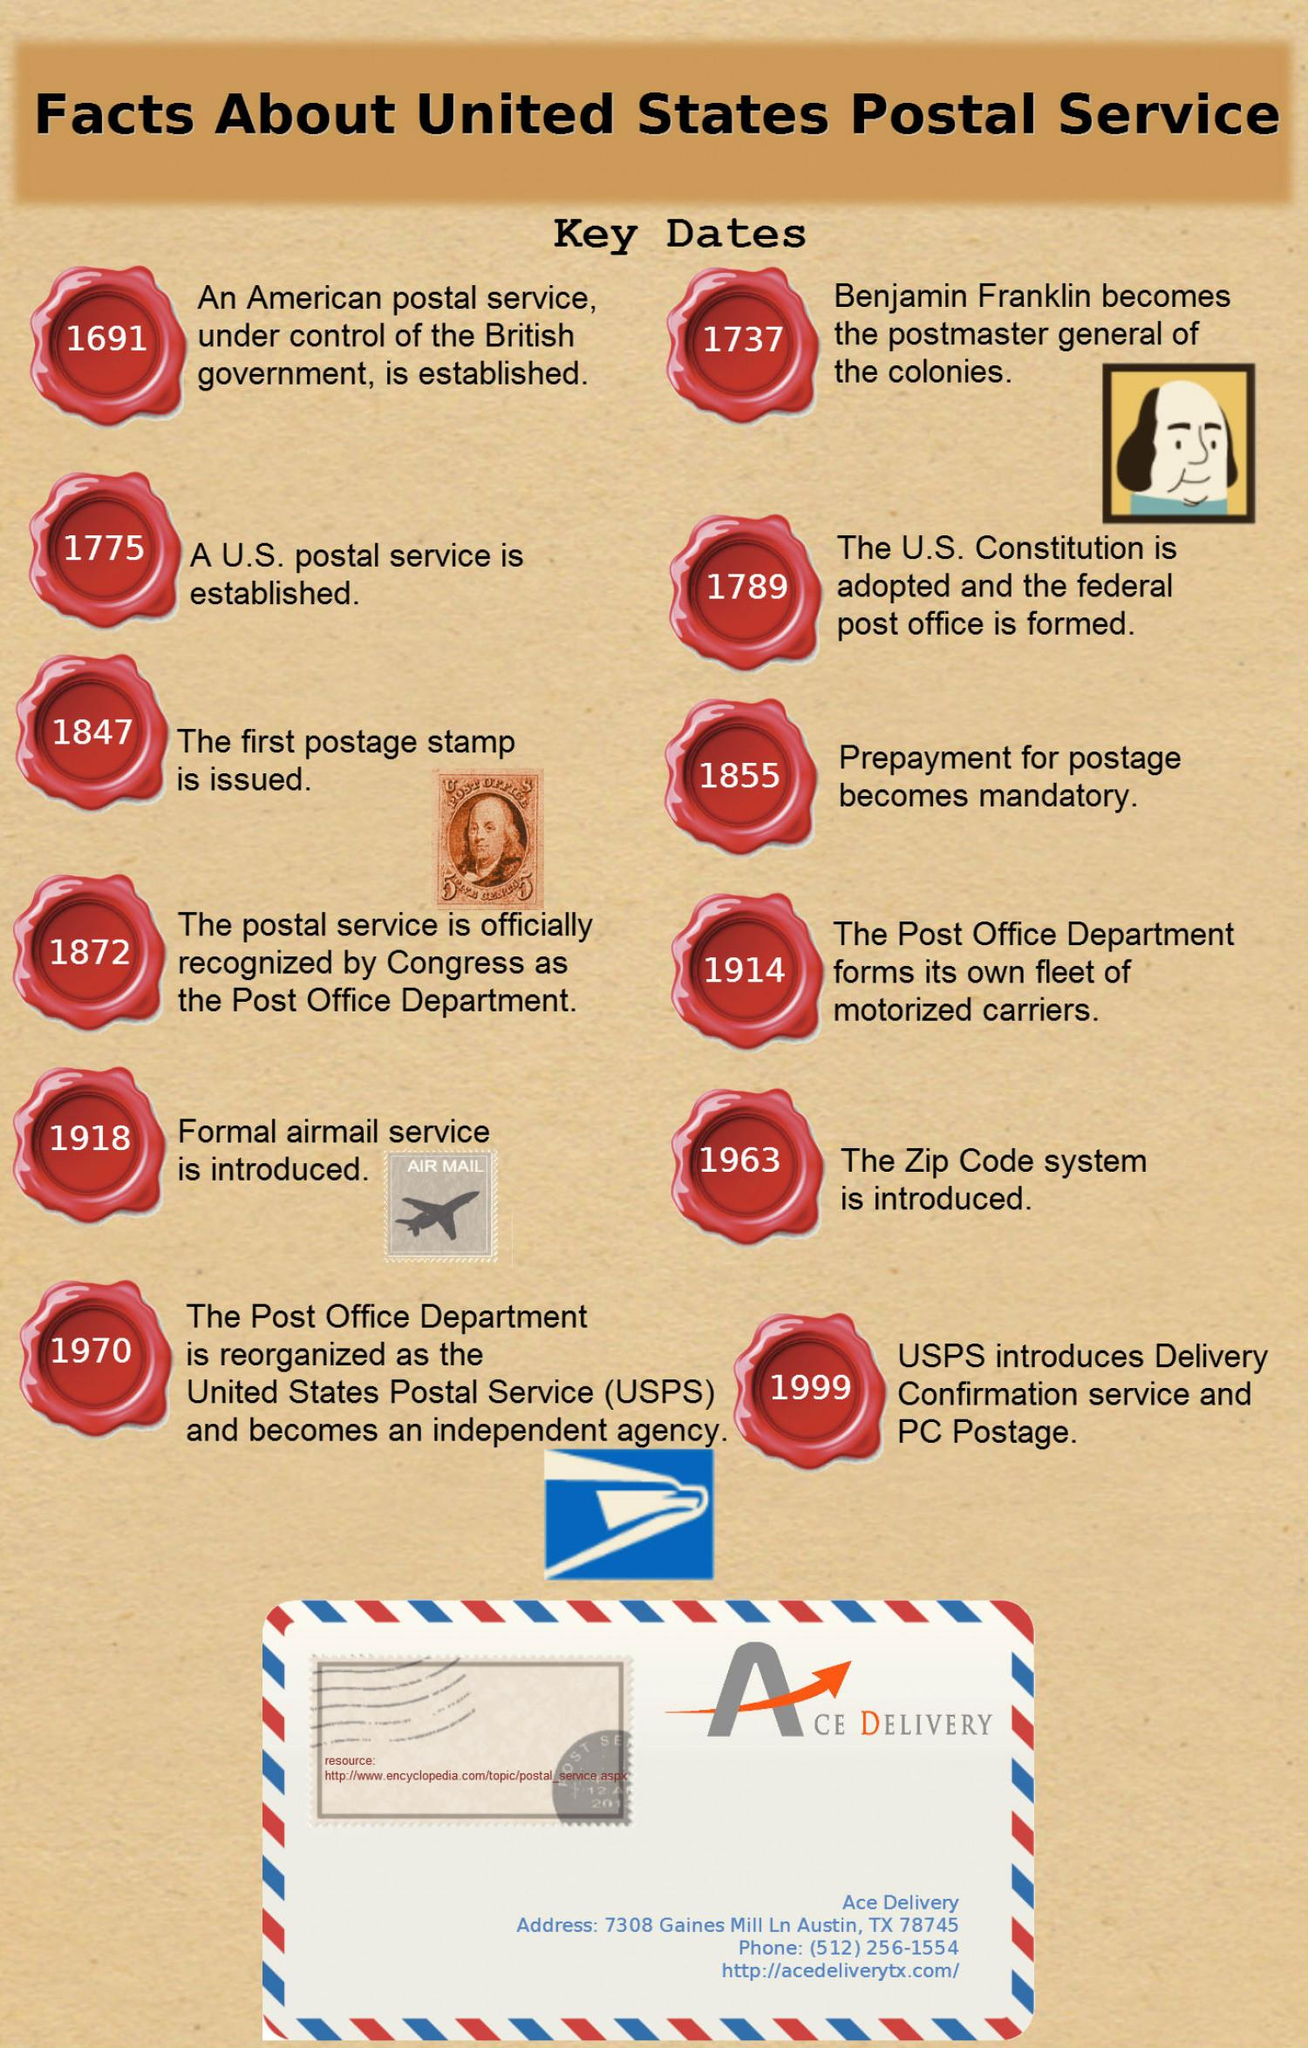Give some essential details in this illustration. In the year 1918, the United States Postal Service introduced a formal airmail service. The Zip Code System was introduced in the United States postal service in 1963. The postmaster general of the colonies in the United States was Benjamin Franklin, who held the position in 1737. The first postage stamp was issued in the United States in 1847. 